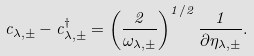Convert formula to latex. <formula><loc_0><loc_0><loc_500><loc_500>c _ { \lambda , \pm } - c _ { \lambda , \pm } ^ { \dagger } = \left ( \frac { 2 } { \omega _ { \lambda , \pm } } \right ) ^ { 1 / 2 } \frac { 1 } { \partial \eta _ { \lambda , \pm } } .</formula> 